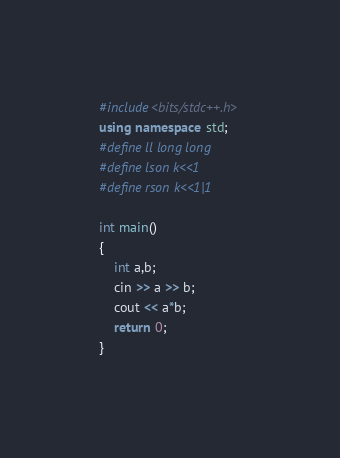Convert code to text. <code><loc_0><loc_0><loc_500><loc_500><_C++_>#include<bits/stdc++.h>
using namespace std;
#define ll long long
#define lson k<<1
#define rson k<<1|1

int main()
{
    int a,b;
    cin >> a >> b;
    cout << a*b;
    return 0;
}
</code> 